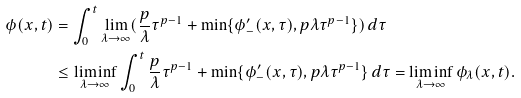Convert formula to latex. <formula><loc_0><loc_0><loc_500><loc_500>\phi ( x , t ) & = \int _ { 0 } ^ { t } \lim _ { \lambda \to \infty } ( \frac { p } { \lambda } \tau ^ { p - 1 } + \min \{ \phi _ { - } ^ { \prime } ( x , \tau ) , p \lambda \tau ^ { p - 1 } \} ) \, d \tau \\ & \leq \liminf _ { \lambda \to \infty } \int _ { 0 } ^ { t } \frac { p } { \lambda } \tau ^ { p - 1 } + \min \{ \phi _ { - } ^ { \prime } ( x , \tau ) , p \lambda \tau ^ { p - 1 } \} \, d \tau = \liminf _ { \lambda \to \infty } \phi _ { \lambda } ( x , t ) .</formula> 